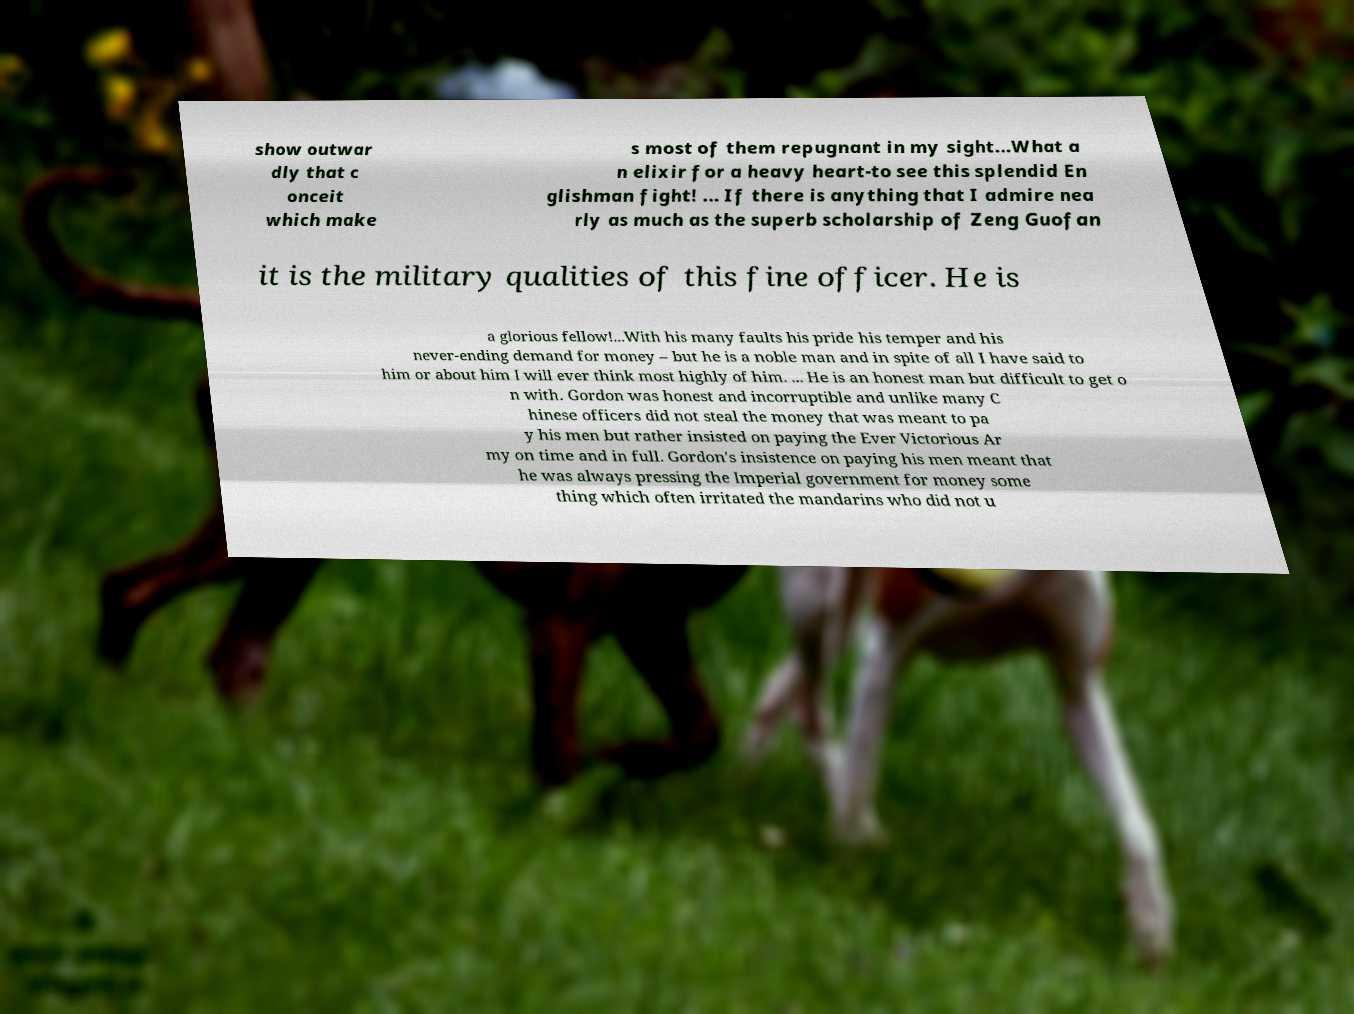Could you extract and type out the text from this image? show outwar dly that c onceit which make s most of them repugnant in my sight...What a n elixir for a heavy heart-to see this splendid En glishman fight! ... If there is anything that I admire nea rly as much as the superb scholarship of Zeng Guofan it is the military qualities of this fine officer. He is a glorious fellow!...With his many faults his pride his temper and his never-ending demand for money – but he is a noble man and in spite of all I have said to him or about him I will ever think most highly of him. ... He is an honest man but difficult to get o n with. Gordon was honest and incorruptible and unlike many C hinese officers did not steal the money that was meant to pa y his men but rather insisted on paying the Ever Victorious Ar my on time and in full. Gordon's insistence on paying his men meant that he was always pressing the Imperial government for money some thing which often irritated the mandarins who did not u 